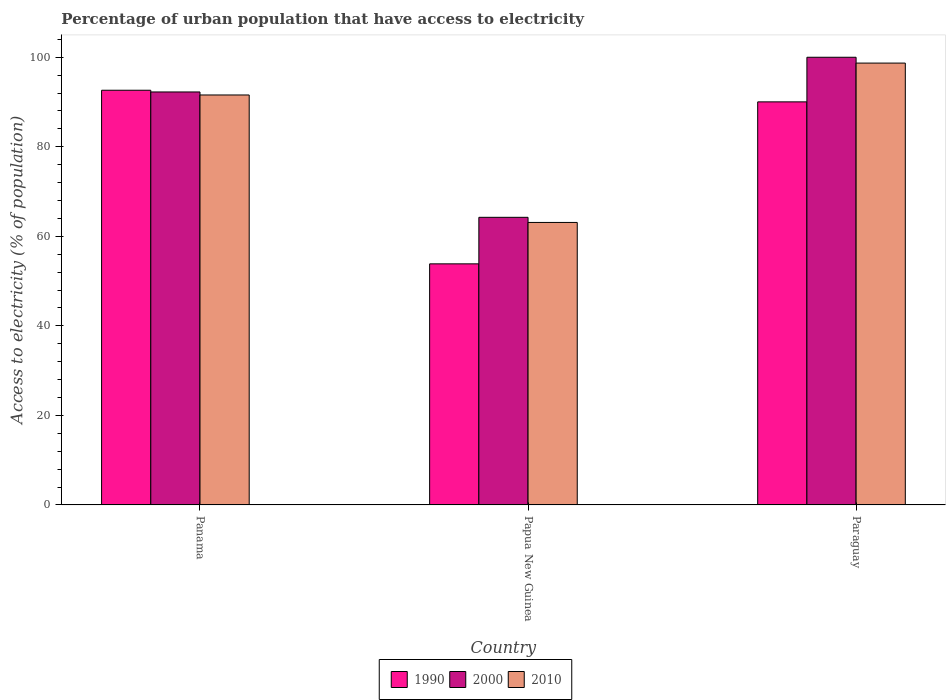Are the number of bars on each tick of the X-axis equal?
Keep it short and to the point. Yes. How many bars are there on the 1st tick from the right?
Provide a succinct answer. 3. What is the label of the 1st group of bars from the left?
Keep it short and to the point. Panama. What is the percentage of urban population that have access to electricity in 2010 in Papua New Guinea?
Provide a short and direct response. 63.1. Across all countries, what is the maximum percentage of urban population that have access to electricity in 2000?
Provide a succinct answer. 100. Across all countries, what is the minimum percentage of urban population that have access to electricity in 2010?
Ensure brevity in your answer.  63.1. In which country was the percentage of urban population that have access to electricity in 1990 maximum?
Your answer should be very brief. Panama. In which country was the percentage of urban population that have access to electricity in 2000 minimum?
Keep it short and to the point. Papua New Guinea. What is the total percentage of urban population that have access to electricity in 2010 in the graph?
Provide a succinct answer. 253.37. What is the difference between the percentage of urban population that have access to electricity in 1990 in Panama and that in Papua New Guinea?
Ensure brevity in your answer.  38.78. What is the difference between the percentage of urban population that have access to electricity in 2010 in Papua New Guinea and the percentage of urban population that have access to electricity in 1990 in Paraguay?
Make the answer very short. -26.93. What is the average percentage of urban population that have access to electricity in 1990 per country?
Provide a succinct answer. 78.84. What is the difference between the percentage of urban population that have access to electricity of/in 2000 and percentage of urban population that have access to electricity of/in 2010 in Papua New Guinea?
Provide a short and direct response. 1.14. What is the ratio of the percentage of urban population that have access to electricity in 1990 in Panama to that in Papua New Guinea?
Offer a very short reply. 1.72. Is the percentage of urban population that have access to electricity in 1990 in Panama less than that in Paraguay?
Keep it short and to the point. No. What is the difference between the highest and the second highest percentage of urban population that have access to electricity in 1990?
Give a very brief answer. -2.6. What is the difference between the highest and the lowest percentage of urban population that have access to electricity in 2000?
Provide a succinct answer. 35.75. In how many countries, is the percentage of urban population that have access to electricity in 1990 greater than the average percentage of urban population that have access to electricity in 1990 taken over all countries?
Your response must be concise. 2. What does the 3rd bar from the left in Panama represents?
Offer a terse response. 2010. What does the 3rd bar from the right in Papua New Guinea represents?
Make the answer very short. 1990. Is it the case that in every country, the sum of the percentage of urban population that have access to electricity in 2000 and percentage of urban population that have access to electricity in 1990 is greater than the percentage of urban population that have access to electricity in 2010?
Provide a succinct answer. Yes. How many countries are there in the graph?
Ensure brevity in your answer.  3. Are the values on the major ticks of Y-axis written in scientific E-notation?
Make the answer very short. No. Where does the legend appear in the graph?
Your response must be concise. Bottom center. What is the title of the graph?
Make the answer very short. Percentage of urban population that have access to electricity. What is the label or title of the Y-axis?
Your answer should be very brief. Access to electricity (% of population). What is the Access to electricity (% of population) of 1990 in Panama?
Your answer should be very brief. 92.63. What is the Access to electricity (% of population) of 2000 in Panama?
Give a very brief answer. 92.25. What is the Access to electricity (% of population) in 2010 in Panama?
Keep it short and to the point. 91.57. What is the Access to electricity (% of population) in 1990 in Papua New Guinea?
Make the answer very short. 53.85. What is the Access to electricity (% of population) of 2000 in Papua New Guinea?
Give a very brief answer. 64.25. What is the Access to electricity (% of population) in 2010 in Papua New Guinea?
Make the answer very short. 63.1. What is the Access to electricity (% of population) in 1990 in Paraguay?
Provide a succinct answer. 90.04. What is the Access to electricity (% of population) of 2000 in Paraguay?
Keep it short and to the point. 100. What is the Access to electricity (% of population) of 2010 in Paraguay?
Offer a very short reply. 98.7. Across all countries, what is the maximum Access to electricity (% of population) of 1990?
Provide a short and direct response. 92.63. Across all countries, what is the maximum Access to electricity (% of population) of 2000?
Keep it short and to the point. 100. Across all countries, what is the maximum Access to electricity (% of population) in 2010?
Provide a short and direct response. 98.7. Across all countries, what is the minimum Access to electricity (% of population) of 1990?
Your answer should be compact. 53.85. Across all countries, what is the minimum Access to electricity (% of population) of 2000?
Provide a short and direct response. 64.25. Across all countries, what is the minimum Access to electricity (% of population) in 2010?
Your response must be concise. 63.1. What is the total Access to electricity (% of population) of 1990 in the graph?
Your response must be concise. 236.52. What is the total Access to electricity (% of population) of 2000 in the graph?
Your answer should be very brief. 256.49. What is the total Access to electricity (% of population) in 2010 in the graph?
Your answer should be very brief. 253.37. What is the difference between the Access to electricity (% of population) of 1990 in Panama and that in Papua New Guinea?
Your answer should be compact. 38.78. What is the difference between the Access to electricity (% of population) in 2000 in Panama and that in Papua New Guinea?
Your response must be concise. 28. What is the difference between the Access to electricity (% of population) of 2010 in Panama and that in Papua New Guinea?
Your answer should be very brief. 28.47. What is the difference between the Access to electricity (% of population) of 1990 in Panama and that in Paraguay?
Offer a very short reply. 2.6. What is the difference between the Access to electricity (% of population) in 2000 in Panama and that in Paraguay?
Offer a very short reply. -7.75. What is the difference between the Access to electricity (% of population) of 2010 in Panama and that in Paraguay?
Give a very brief answer. -7.13. What is the difference between the Access to electricity (% of population) of 1990 in Papua New Guinea and that in Paraguay?
Give a very brief answer. -36.18. What is the difference between the Access to electricity (% of population) in 2000 in Papua New Guinea and that in Paraguay?
Ensure brevity in your answer.  -35.76. What is the difference between the Access to electricity (% of population) in 2010 in Papua New Guinea and that in Paraguay?
Make the answer very short. -35.6. What is the difference between the Access to electricity (% of population) in 1990 in Panama and the Access to electricity (% of population) in 2000 in Papua New Guinea?
Offer a terse response. 28.39. What is the difference between the Access to electricity (% of population) in 1990 in Panama and the Access to electricity (% of population) in 2010 in Papua New Guinea?
Give a very brief answer. 29.53. What is the difference between the Access to electricity (% of population) of 2000 in Panama and the Access to electricity (% of population) of 2010 in Papua New Guinea?
Offer a very short reply. 29.15. What is the difference between the Access to electricity (% of population) in 1990 in Panama and the Access to electricity (% of population) in 2000 in Paraguay?
Provide a short and direct response. -7.37. What is the difference between the Access to electricity (% of population) in 1990 in Panama and the Access to electricity (% of population) in 2010 in Paraguay?
Your response must be concise. -6.07. What is the difference between the Access to electricity (% of population) in 2000 in Panama and the Access to electricity (% of population) in 2010 in Paraguay?
Offer a very short reply. -6.45. What is the difference between the Access to electricity (% of population) of 1990 in Papua New Guinea and the Access to electricity (% of population) of 2000 in Paraguay?
Offer a very short reply. -46.15. What is the difference between the Access to electricity (% of population) in 1990 in Papua New Guinea and the Access to electricity (% of population) in 2010 in Paraguay?
Provide a short and direct response. -44.85. What is the difference between the Access to electricity (% of population) of 2000 in Papua New Guinea and the Access to electricity (% of population) of 2010 in Paraguay?
Provide a short and direct response. -34.45. What is the average Access to electricity (% of population) of 1990 per country?
Offer a terse response. 78.84. What is the average Access to electricity (% of population) in 2000 per country?
Offer a terse response. 85.5. What is the average Access to electricity (% of population) in 2010 per country?
Give a very brief answer. 84.46. What is the difference between the Access to electricity (% of population) in 1990 and Access to electricity (% of population) in 2000 in Panama?
Ensure brevity in your answer.  0.39. What is the difference between the Access to electricity (% of population) in 1990 and Access to electricity (% of population) in 2010 in Panama?
Your answer should be very brief. 1.06. What is the difference between the Access to electricity (% of population) of 2000 and Access to electricity (% of population) of 2010 in Panama?
Provide a succinct answer. 0.67. What is the difference between the Access to electricity (% of population) in 1990 and Access to electricity (% of population) in 2000 in Papua New Guinea?
Keep it short and to the point. -10.39. What is the difference between the Access to electricity (% of population) in 1990 and Access to electricity (% of population) in 2010 in Papua New Guinea?
Make the answer very short. -9.25. What is the difference between the Access to electricity (% of population) of 2000 and Access to electricity (% of population) of 2010 in Papua New Guinea?
Offer a terse response. 1.14. What is the difference between the Access to electricity (% of population) of 1990 and Access to electricity (% of population) of 2000 in Paraguay?
Your response must be concise. -9.96. What is the difference between the Access to electricity (% of population) in 1990 and Access to electricity (% of population) in 2010 in Paraguay?
Keep it short and to the point. -8.66. What is the difference between the Access to electricity (% of population) of 2000 and Access to electricity (% of population) of 2010 in Paraguay?
Keep it short and to the point. 1.3. What is the ratio of the Access to electricity (% of population) in 1990 in Panama to that in Papua New Guinea?
Keep it short and to the point. 1.72. What is the ratio of the Access to electricity (% of population) of 2000 in Panama to that in Papua New Guinea?
Offer a terse response. 1.44. What is the ratio of the Access to electricity (% of population) in 2010 in Panama to that in Papua New Guinea?
Your answer should be very brief. 1.45. What is the ratio of the Access to electricity (% of population) in 1990 in Panama to that in Paraguay?
Your answer should be compact. 1.03. What is the ratio of the Access to electricity (% of population) in 2000 in Panama to that in Paraguay?
Your response must be concise. 0.92. What is the ratio of the Access to electricity (% of population) in 2010 in Panama to that in Paraguay?
Offer a terse response. 0.93. What is the ratio of the Access to electricity (% of population) in 1990 in Papua New Guinea to that in Paraguay?
Offer a very short reply. 0.6. What is the ratio of the Access to electricity (% of population) of 2000 in Papua New Guinea to that in Paraguay?
Offer a very short reply. 0.64. What is the ratio of the Access to electricity (% of population) of 2010 in Papua New Guinea to that in Paraguay?
Offer a very short reply. 0.64. What is the difference between the highest and the second highest Access to electricity (% of population) of 1990?
Give a very brief answer. 2.6. What is the difference between the highest and the second highest Access to electricity (% of population) in 2000?
Your response must be concise. 7.75. What is the difference between the highest and the second highest Access to electricity (% of population) of 2010?
Your response must be concise. 7.13. What is the difference between the highest and the lowest Access to electricity (% of population) in 1990?
Ensure brevity in your answer.  38.78. What is the difference between the highest and the lowest Access to electricity (% of population) of 2000?
Offer a very short reply. 35.76. What is the difference between the highest and the lowest Access to electricity (% of population) of 2010?
Offer a very short reply. 35.6. 